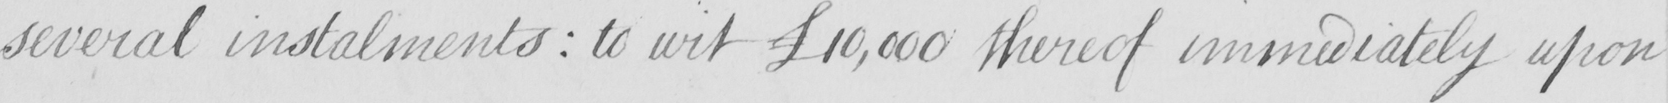Can you tell me what this handwritten text says? several instaments  :  to wit  £10,000 thereof immediately upon 